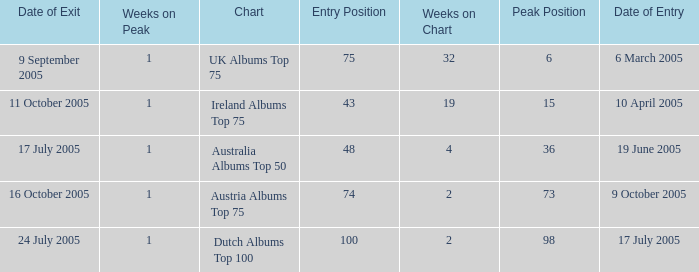What was the total number of weeks on peak for the Ireland Albums Top 75 chart? 1.0. 